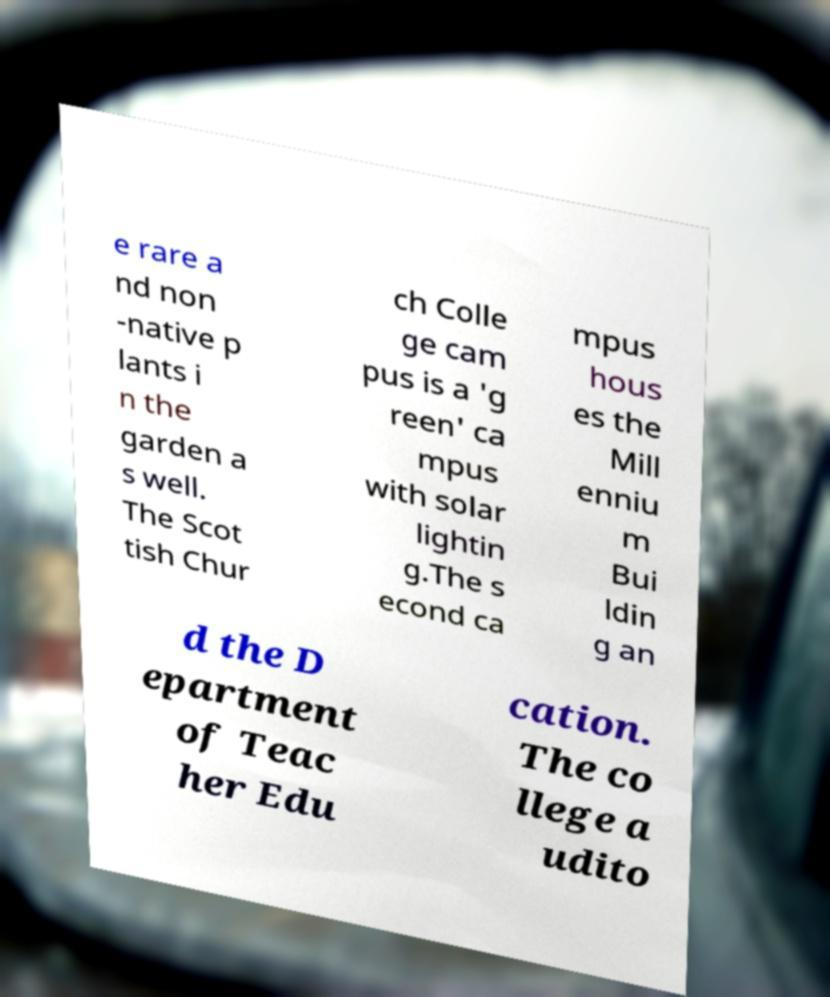Could you assist in decoding the text presented in this image and type it out clearly? e rare a nd non -native p lants i n the garden a s well. The Scot tish Chur ch Colle ge cam pus is a 'g reen' ca mpus with solar lightin g.The s econd ca mpus hous es the Mill enniu m Bui ldin g an d the D epartment of Teac her Edu cation. The co llege a udito 